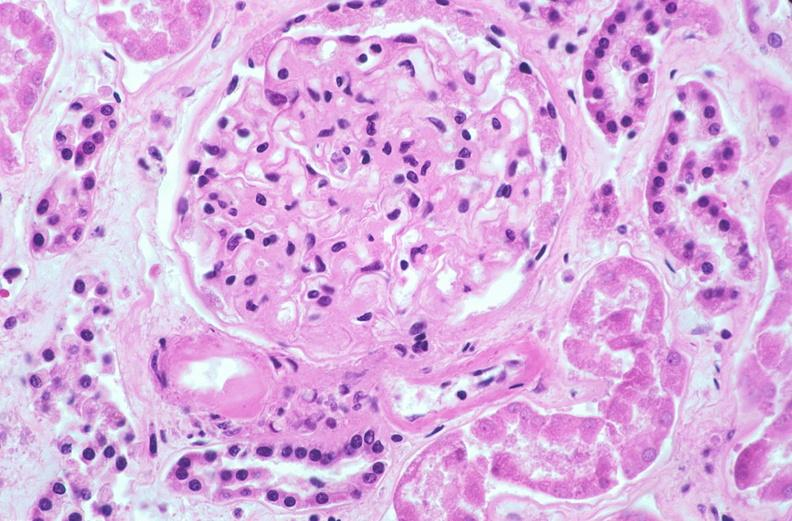does this image show kidney glomerulus, thickened and hyalinized basement membranes fibrin caps due to diabetes mellitus?
Answer the question using a single word or phrase. Yes 